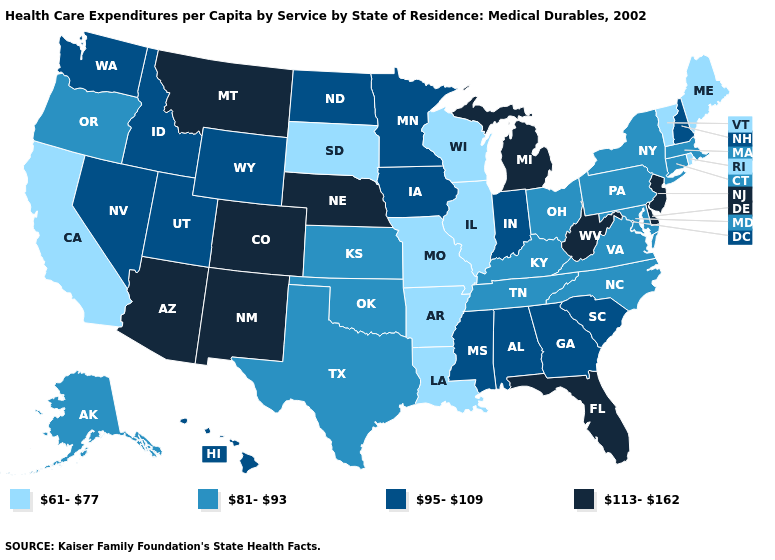Does the map have missing data?
Quick response, please. No. What is the value of Pennsylvania?
Write a very short answer. 81-93. What is the value of South Dakota?
Give a very brief answer. 61-77. Name the states that have a value in the range 61-77?
Give a very brief answer. Arkansas, California, Illinois, Louisiana, Maine, Missouri, Rhode Island, South Dakota, Vermont, Wisconsin. Among the states that border North Dakota , does Montana have the highest value?
Give a very brief answer. Yes. What is the value of Florida?
Concise answer only. 113-162. What is the value of Indiana?
Give a very brief answer. 95-109. Does Mississippi have the highest value in the South?
Keep it brief. No. Does the map have missing data?
Keep it brief. No. Name the states that have a value in the range 95-109?
Answer briefly. Alabama, Georgia, Hawaii, Idaho, Indiana, Iowa, Minnesota, Mississippi, Nevada, New Hampshire, North Dakota, South Carolina, Utah, Washington, Wyoming. What is the value of Florida?
Keep it brief. 113-162. Name the states that have a value in the range 95-109?
Quick response, please. Alabama, Georgia, Hawaii, Idaho, Indiana, Iowa, Minnesota, Mississippi, Nevada, New Hampshire, North Dakota, South Carolina, Utah, Washington, Wyoming. What is the highest value in states that border North Dakota?
Give a very brief answer. 113-162. Which states have the lowest value in the West?
Short answer required. California. What is the value of Massachusetts?
Be succinct. 81-93. 